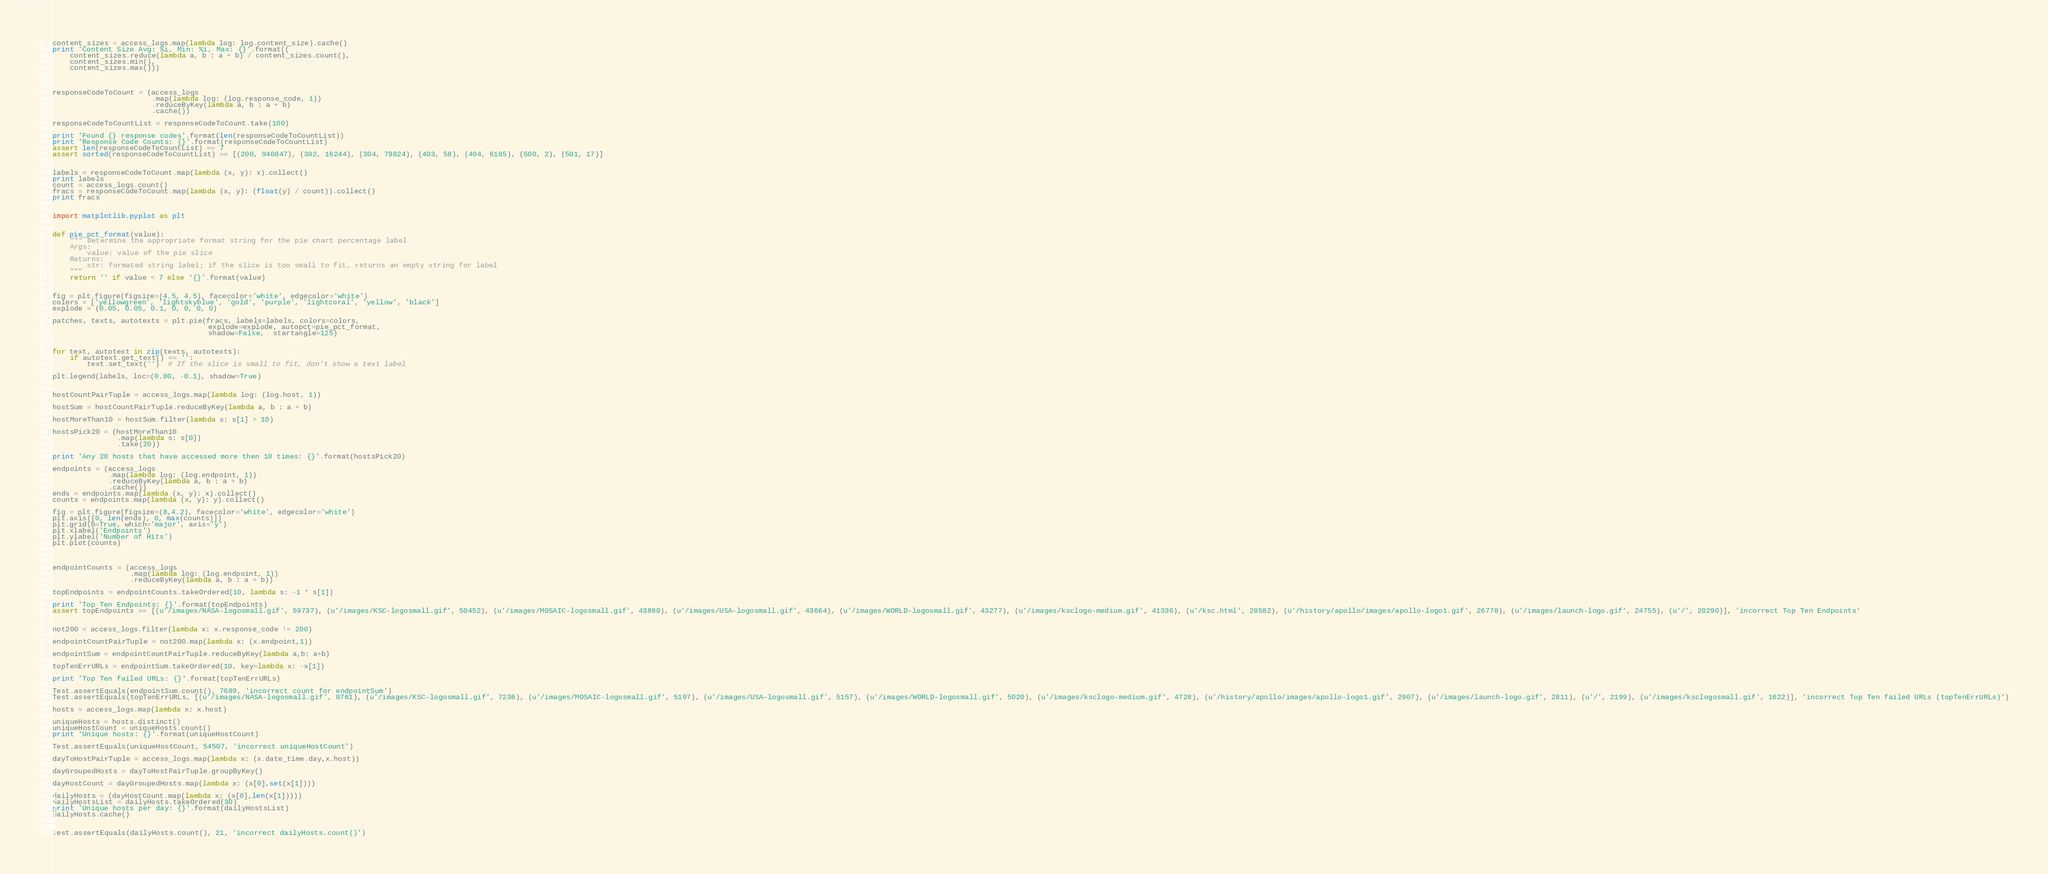Convert code to text. <code><loc_0><loc_0><loc_500><loc_500><_Python_>

content_sizes = access_logs.map(lambda log: log.content_size).cache()
print 'Content Size Avg: %i, Min: %i, Max: {}'.format((
    content_sizes.reduce(lambda a, b : a + b) / content_sizes.count(),
    content_sizes.min(),
    content_sizes.max()))



responseCodeToCount = (access_logs
                       .map(lambda log: (log.response_code, 1))
                       .reduceByKey(lambda a, b : a + b)
                       .cache())

responseCodeToCountList = responseCodeToCount.take(100)

print 'Found {} response codes'.format(len(responseCodeToCountList))
print 'Response Code Counts: {}'.format(responseCodeToCountList)
assert len(responseCodeToCountList) == 7
assert sorted(responseCodeToCountList) == [(200, 940847), (302, 16244), (304, 79824), (403, 58), (404, 6185), (500, 2), (501, 17)]


labels = responseCodeToCount.map(lambda (x, y): x).collect()
print labels
count = access_logs.count()
fracs = responseCodeToCount.map(lambda (x, y): (float(y) / count)).collect()
print fracs


import matplotlib.pyplot as plt


def pie_pct_format(value):
    """ Determine the appropriate format string for the pie chart percentage label
    Args:
        value: value of the pie slice
    Returns:
        str: formated string label; if the slice is too small to fit, returns an empty string for label
    """
    return '' if value < 7 else '{}'.format(value)


fig = plt.figure(figsize=(4.5, 4.5), facecolor='white', edgecolor='white')
colors = ['yellowgreen', 'lightskyblue', 'gold', 'purple', 'lightcoral', 'yellow', 'black']
explode = (0.05, 0.05, 0.1, 0, 0, 0, 0)

patches, texts, autotexts = plt.pie(fracs, labels=labels, colors=colors,
                                    explode=explode, autopct=pie_pct_format,
                                    shadow=False,  startangle=125)


for text, autotext in zip(texts, autotexts):
    if autotext.get_text() == '':
        text.set_text('')  # If the slice is small to fit, don't show a text label

plt.legend(labels, loc=(0.80, -0.1), shadow=True)


hostCountPairTuple = access_logs.map(lambda log: (log.host, 1))

hostSum = hostCountPairTuple.reduceByKey(lambda a, b : a + b)

hostMoreThan10 = hostSum.filter(lambda s: s[1] > 10)

hostsPick20 = (hostMoreThan10
               .map(lambda s: s[0])
               .take(20))

print 'Any 20 hosts that have accessed more then 10 times: {}'.format(hostsPick20)

endpoints = (access_logs
             .map(lambda log: (log.endpoint, 1))
             .reduceByKey(lambda a, b : a + b)
             .cache())
ends = endpoints.map(lambda (x, y): x).collect()
counts = endpoints.map(lambda (x, y): y).collect()

fig = plt.figure(figsize=(8,4.2), facecolor='white', edgecolor='white')
plt.axis([0, len(ends), 0, max(counts)])
plt.grid(b=True, which='major', axis='y')
plt.xlabel('Endpoints')
plt.ylabel('Number of Hits')
plt.plot(counts)



endpointCounts = (access_logs
                  .map(lambda log: (log.endpoint, 1))
                  .reduceByKey(lambda a, b : a + b))

topEndpoints = endpointCounts.takeOrdered(10, lambda s: -1 * s[1])

print 'Top Ten Endpoints: {}'.format(topEndpoints)
assert topEndpoints == [(u'/images/NASA-logosmall.gif', 59737), (u'/images/KSC-logosmall.gif', 50452), (u'/images/MOSAIC-logosmall.gif', 43890), (u'/images/USA-logosmall.gif', 43664), (u'/images/WORLD-logosmall.gif', 43277), (u'/images/ksclogo-medium.gif', 41336), (u'/ksc.html', 28582), (u'/history/apollo/images/apollo-logo1.gif', 26778), (u'/images/launch-logo.gif', 24755), (u'/', 20290)], 'incorrect Top Ten Endpoints'


not200 = access_logs.filter(lambda x: x.response_code != 200)

endpointCountPairTuple = not200.map(lambda x: (x.endpoint,1))

endpointSum = endpointCountPairTuple.reduceByKey(lambda a,b: a+b)

topTenErrURLs = endpointSum.takeOrdered(10, key=lambda x: -x[1])

print 'Top Ten failed URLs: {}'.format(topTenErrURLs)

Test.assertEquals(endpointSum.count(), 7689, 'incorrect count for endpointSum')
Test.assertEquals(topTenErrURLs, [(u'/images/NASA-logosmall.gif', 8761), (u'/images/KSC-logosmall.gif', 7236), (u'/images/MOSAIC-logosmall.gif', 5197), (u'/images/USA-logosmall.gif', 5157), (u'/images/WORLD-logosmall.gif', 5020), (u'/images/ksclogo-medium.gif', 4728), (u'/history/apollo/images/apollo-logo1.gif', 2907), (u'/images/launch-logo.gif', 2811), (u'/', 2199), (u'/images/ksclogosmall.gif', 1622)], 'incorrect Top Ten failed URLs (topTenErrURLs)')

hosts = access_logs.map(lambda x: x.host)

uniqueHosts = hosts.distinct()
uniqueHostCount = uniqueHosts.count()
print 'Unique hosts: {}'.format(uniqueHostCount)

Test.assertEquals(uniqueHostCount, 54507, 'incorrect uniqueHostCount')

dayToHostPairTuple = access_logs.map(lambda x: (x.date_time.day,x.host))

dayGroupedHosts = dayToHostPairTuple.groupByKey()

dayHostCount = dayGroupedHosts.map(lambda x: (x[0],set(x[1])))

dailyHosts = (dayHostCount.map(lambda x: (x[0],len(x[1]))))
dailyHostsList = dailyHosts.takeOrdered(30)
print 'Unique hosts per day: {}'.format(dailyHostsList)
dailyHosts.cache()


Test.assertEquals(dailyHosts.count(), 21, 'incorrect dailyHosts.count()')</code> 